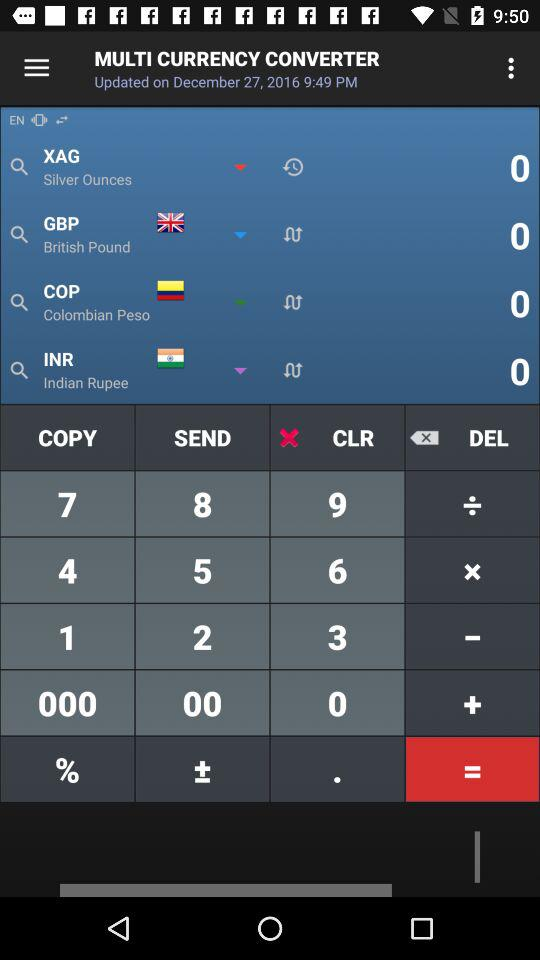When was "MULTI CURRENCY CONVERTER" updated? It was updated on December 27, 2016 at 9:49 p.m. 